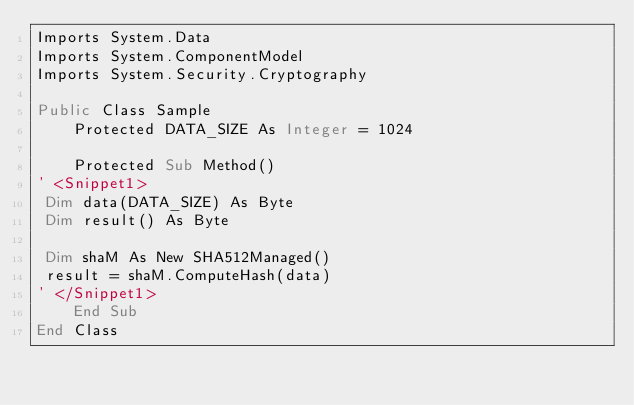<code> <loc_0><loc_0><loc_500><loc_500><_VisualBasic_>Imports System.Data
Imports System.ComponentModel
Imports System.Security.Cryptography

Public Class Sample
    Protected DATA_SIZE As Integer = 1024
    
    Protected Sub Method()
' <Snippet1>
 Dim data(DATA_SIZE) As Byte
 Dim result() As Byte
        
 Dim shaM As New SHA512Managed()
 result = shaM.ComputeHash(data)
' </Snippet1>
    End Sub
End Class
</code> 